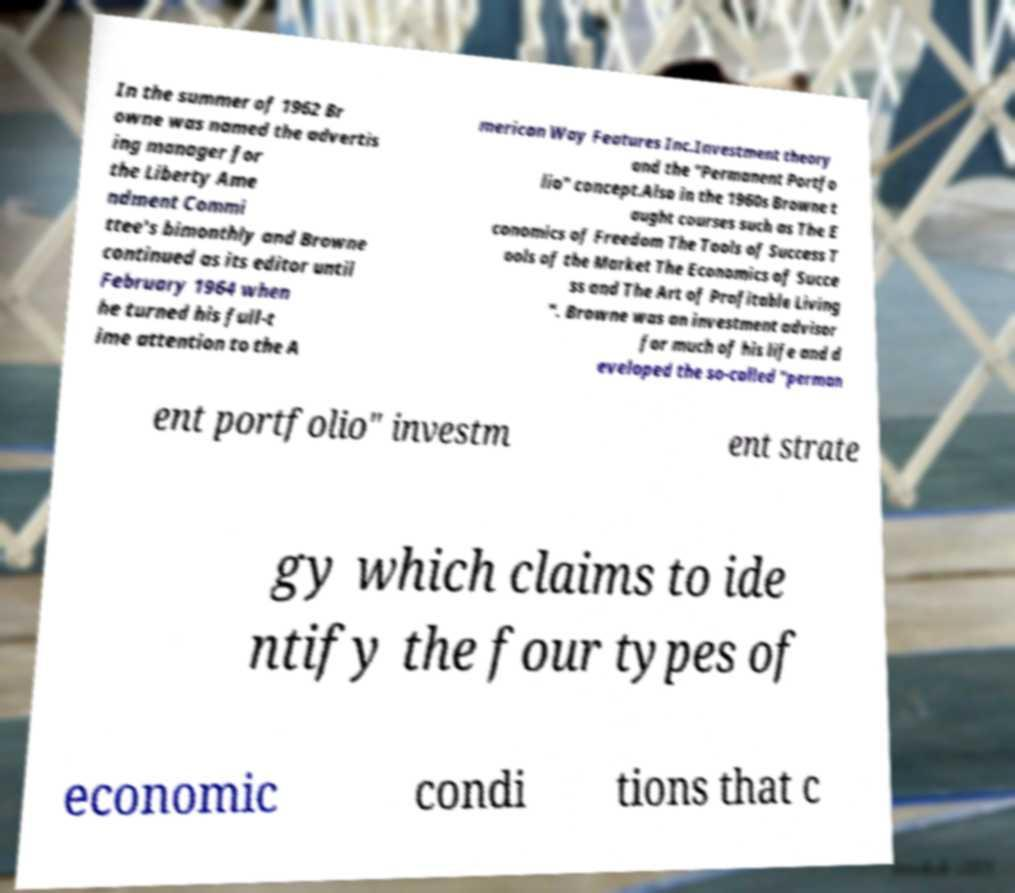Could you extract and type out the text from this image? In the summer of 1962 Br owne was named the advertis ing manager for the Liberty Ame ndment Commi ttee's bimonthly and Browne continued as its editor until February 1964 when he turned his full-t ime attention to the A merican Way Features Inc.Investment theory and the "Permanent Portfo lio" concept.Also in the 1960s Browne t aught courses such as The E conomics of Freedom The Tools of Success T ools of the Market The Economics of Succe ss and The Art of Profitable Living ". Browne was an investment advisor for much of his life and d eveloped the so-called "perman ent portfolio" investm ent strate gy which claims to ide ntify the four types of economic condi tions that c 